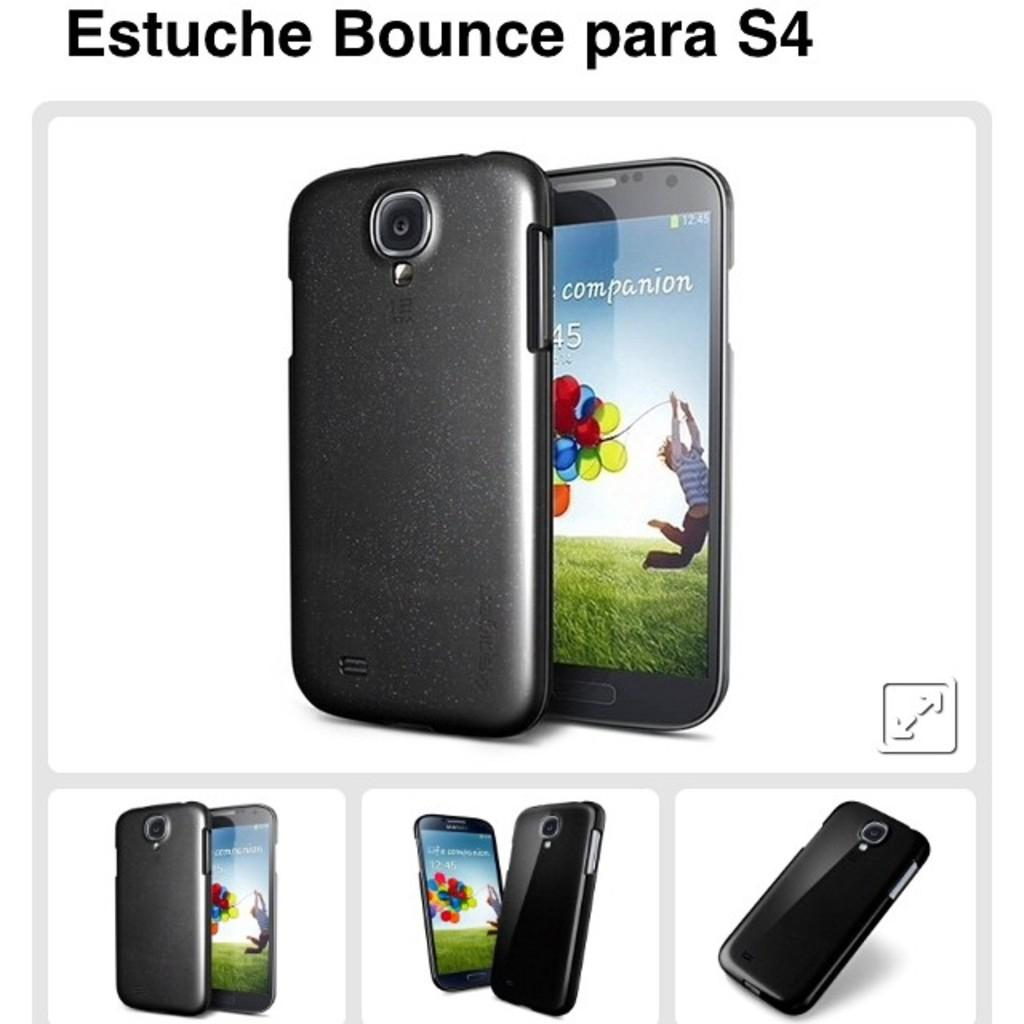<image>
Present a compact description of the photo's key features. An S4 cell phone is shown in different positions. 